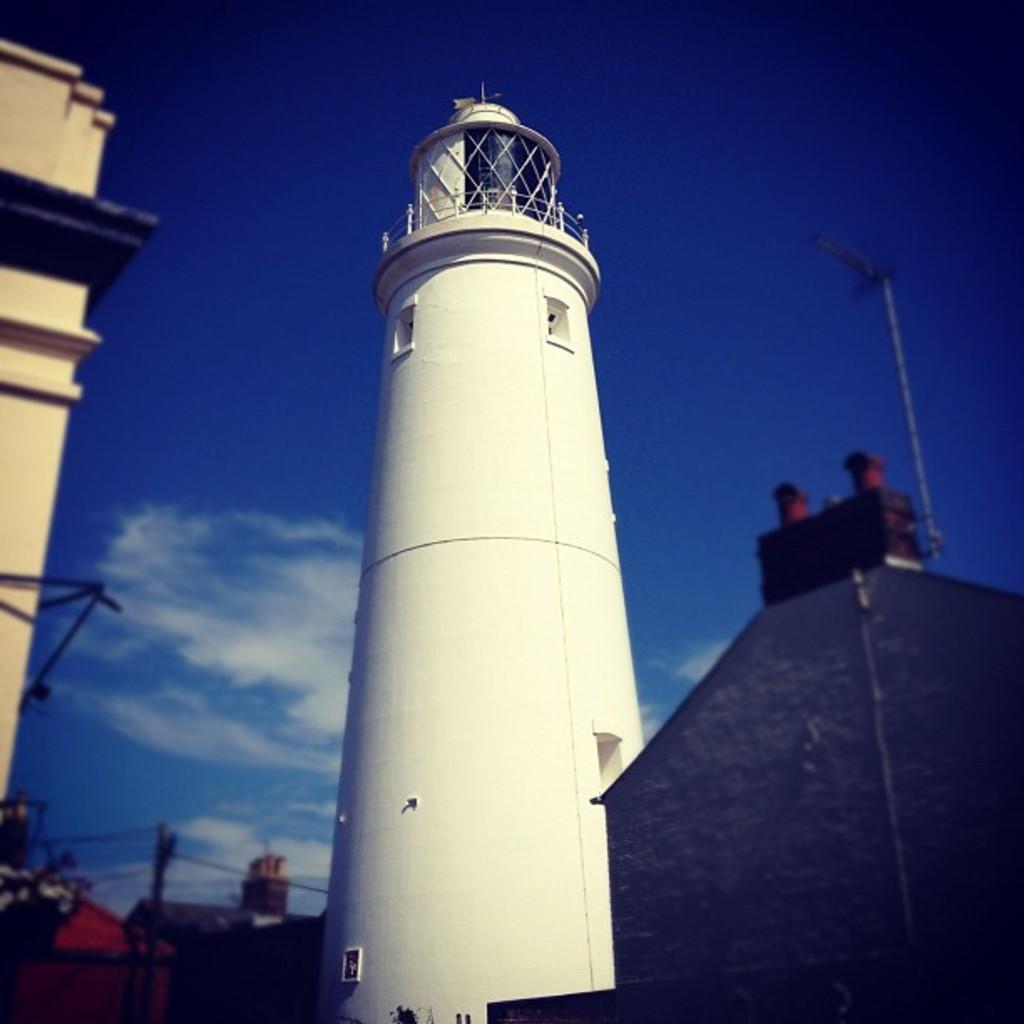Could you give a brief overview of what you see in this image? In this image we can see tower, buildings, pole and blue sky. These are clouds. To this town there is a railing. 